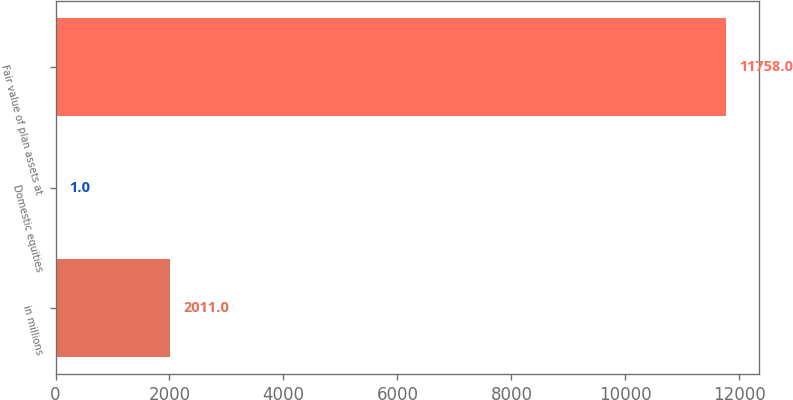Convert chart to OTSL. <chart><loc_0><loc_0><loc_500><loc_500><bar_chart><fcel>in millions<fcel>Domestic equities<fcel>Fair value of plan assets at<nl><fcel>2011<fcel>1<fcel>11758<nl></chart> 